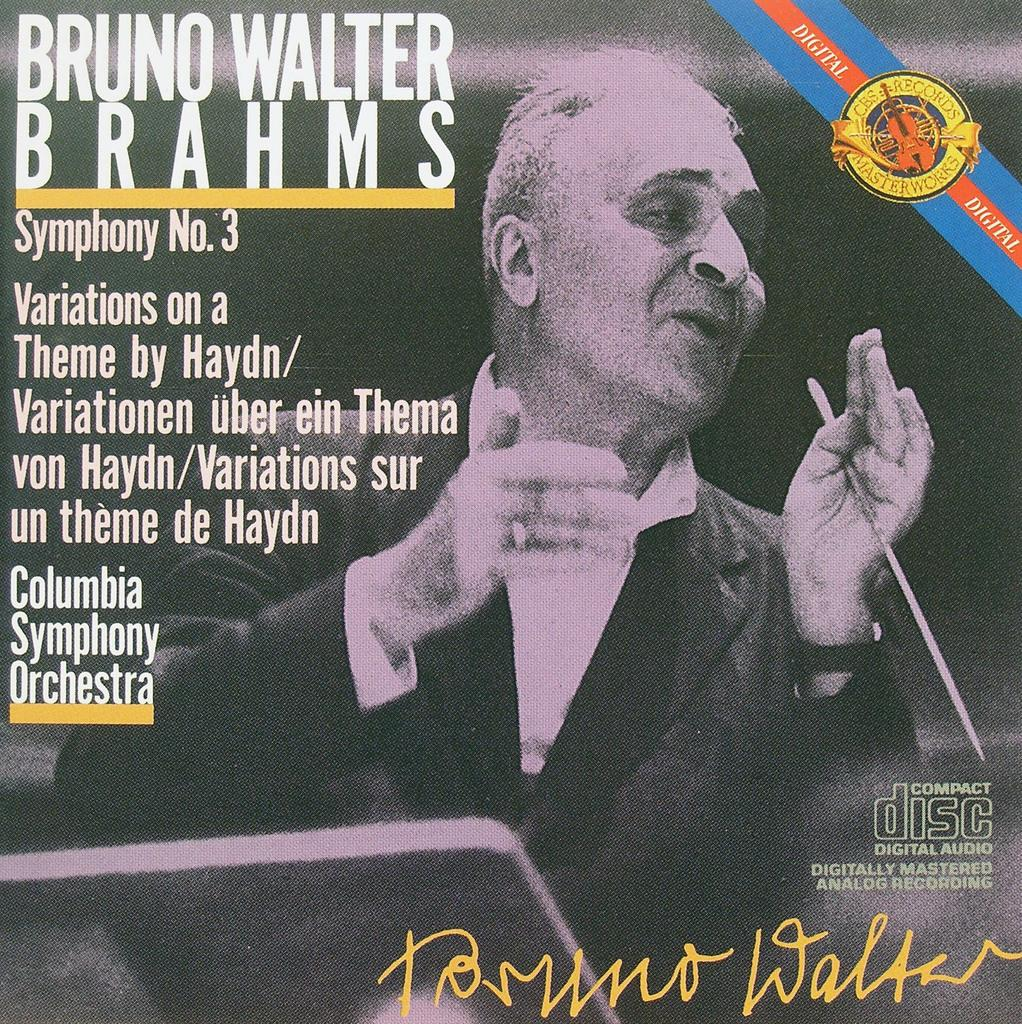What is the main subject of the image? There is a person in the image. What is the person holding in the image? The person is holding a stick. What type of written information is visible in the image? There is text visible in the image. Is there any branding or symbolism in the image? Yes, there is a logo in the image. Can you identify any personal touch or identification in the image? Yes, there is a signature in the image. How much debt is the person in the image currently facing? There is no information about the person's debt in the image. Can you see the person's foot in the image? The person's foot is not visible in the image. 